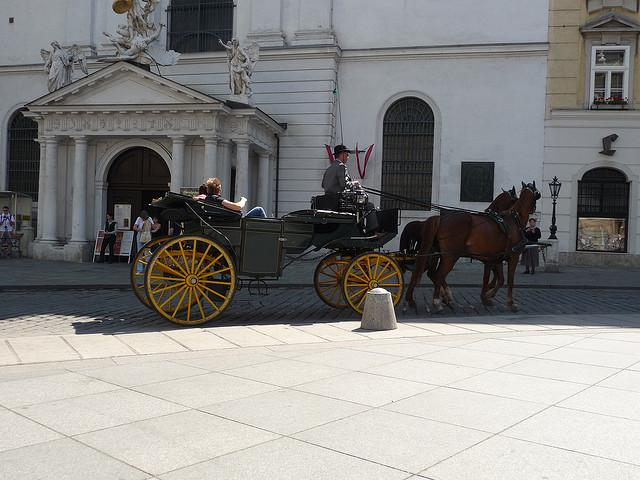What is being held by the person sitting highest?

Choices:
A) wagon wheels
B) spurs
C) tickets
D) reins reins 